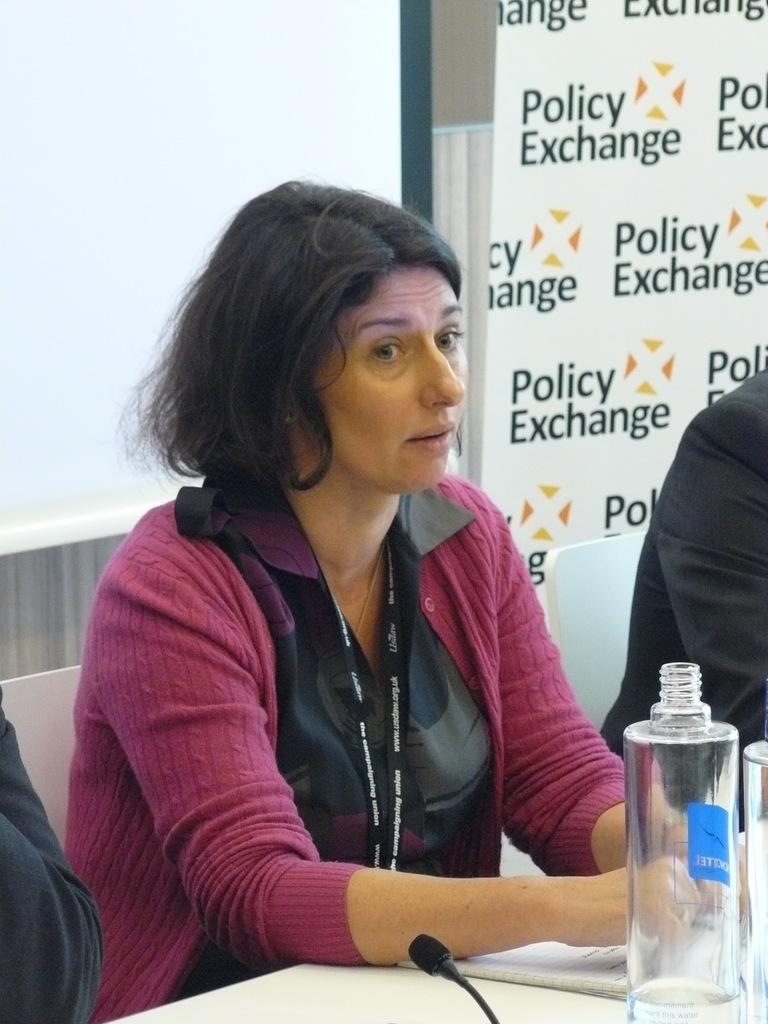Provide a one-sentence caption for the provided image. A woman sitting at a table, looking at someone, the wall behind says Polcy exchange. 